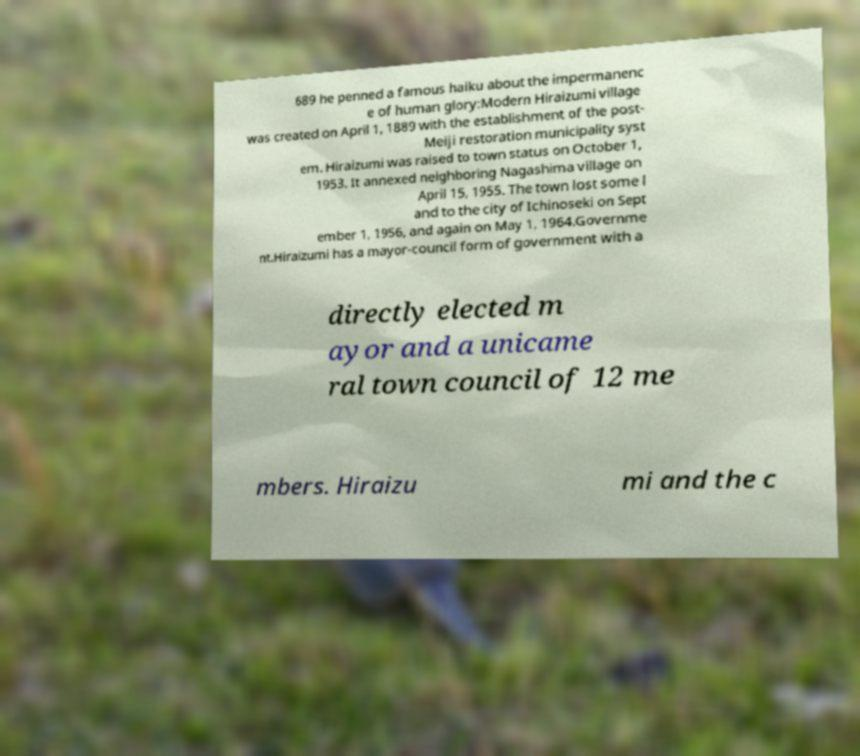Can you read and provide the text displayed in the image?This photo seems to have some interesting text. Can you extract and type it out for me? 689 he penned a famous haiku about the impermanenc e of human glory:Modern Hiraizumi village was created on April 1, 1889 with the establishment of the post- Meiji restoration municipality syst em. Hiraizumi was raised to town status on October 1, 1953. It annexed neighboring Nagashima village on April 15, 1955. The town lost some l and to the city of Ichinoseki on Sept ember 1, 1956, and again on May 1, 1964.Governme nt.Hiraizumi has a mayor-council form of government with a directly elected m ayor and a unicame ral town council of 12 me mbers. Hiraizu mi and the c 